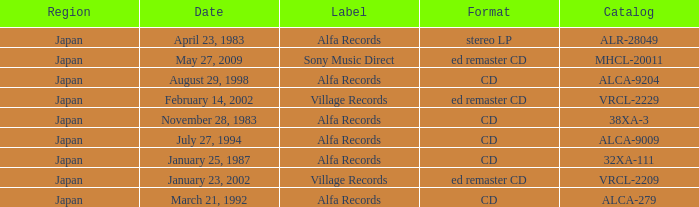Which region is identified as 38xa-3 in the catalog? Japan. 